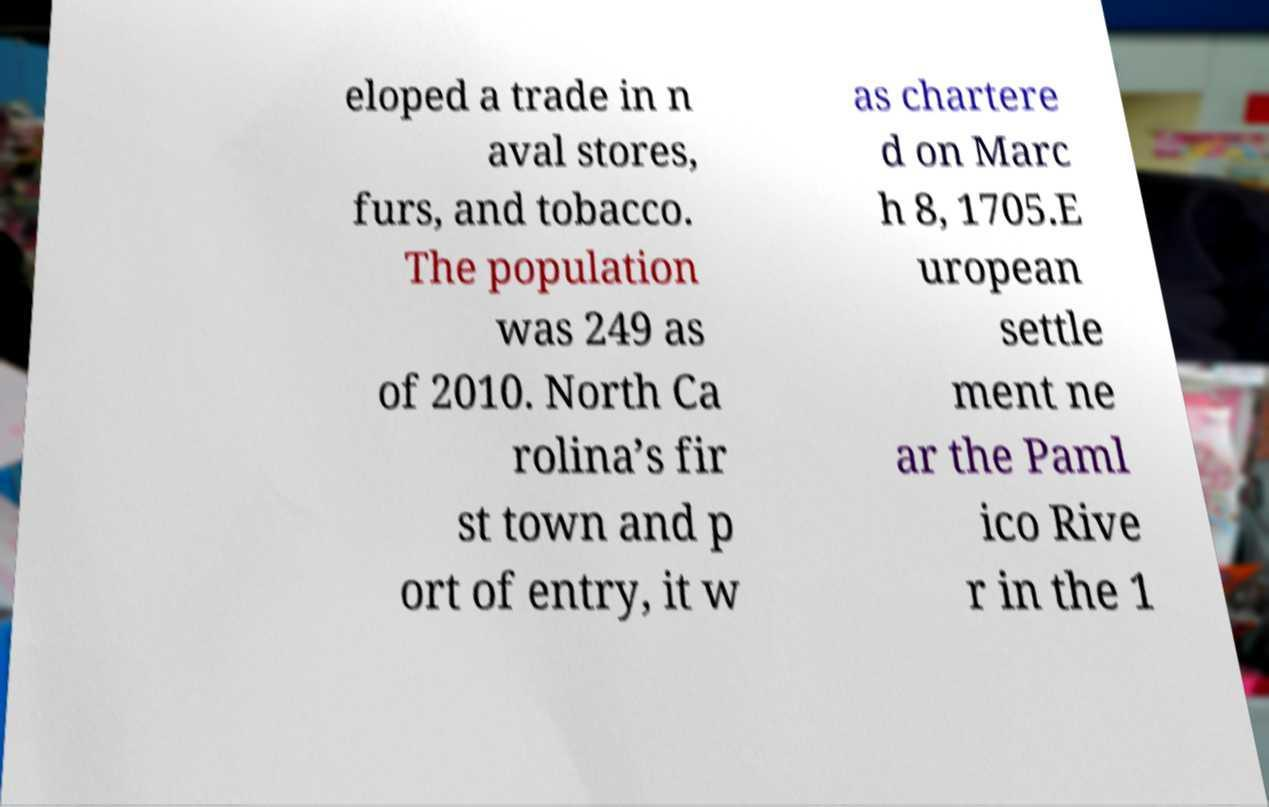Could you extract and type out the text from this image? eloped a trade in n aval stores, furs, and tobacco. The population was 249 as of 2010. North Ca rolina’s fir st town and p ort of entry, it w as chartere d on Marc h 8, 1705.E uropean settle ment ne ar the Paml ico Rive r in the 1 